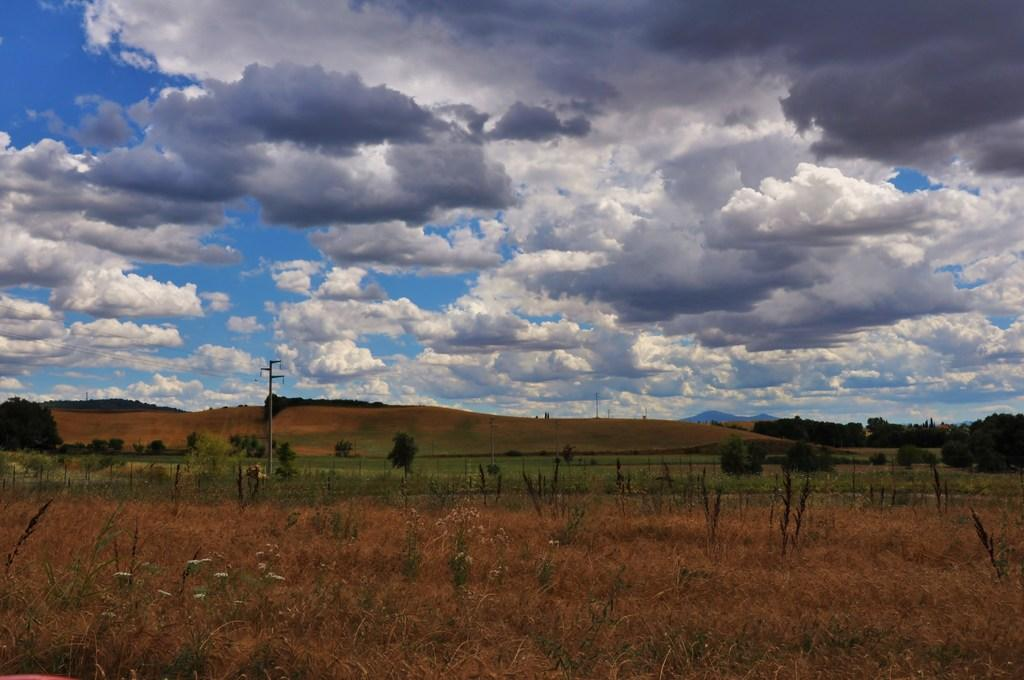What type of vegetation can be seen in the image? There are plants, grass, and trees in the image. What is the man-made object present in the image? There is a current pole in the image. What is visible in the background of the image? The sky is visible in the image, and clouds are present in the sky. How many rings can be seen on the tree in the image? There are no rings visible on any trees in the image, as rings are typically found on tree trunks when they are cut down, and no trees are cut down in the image. 